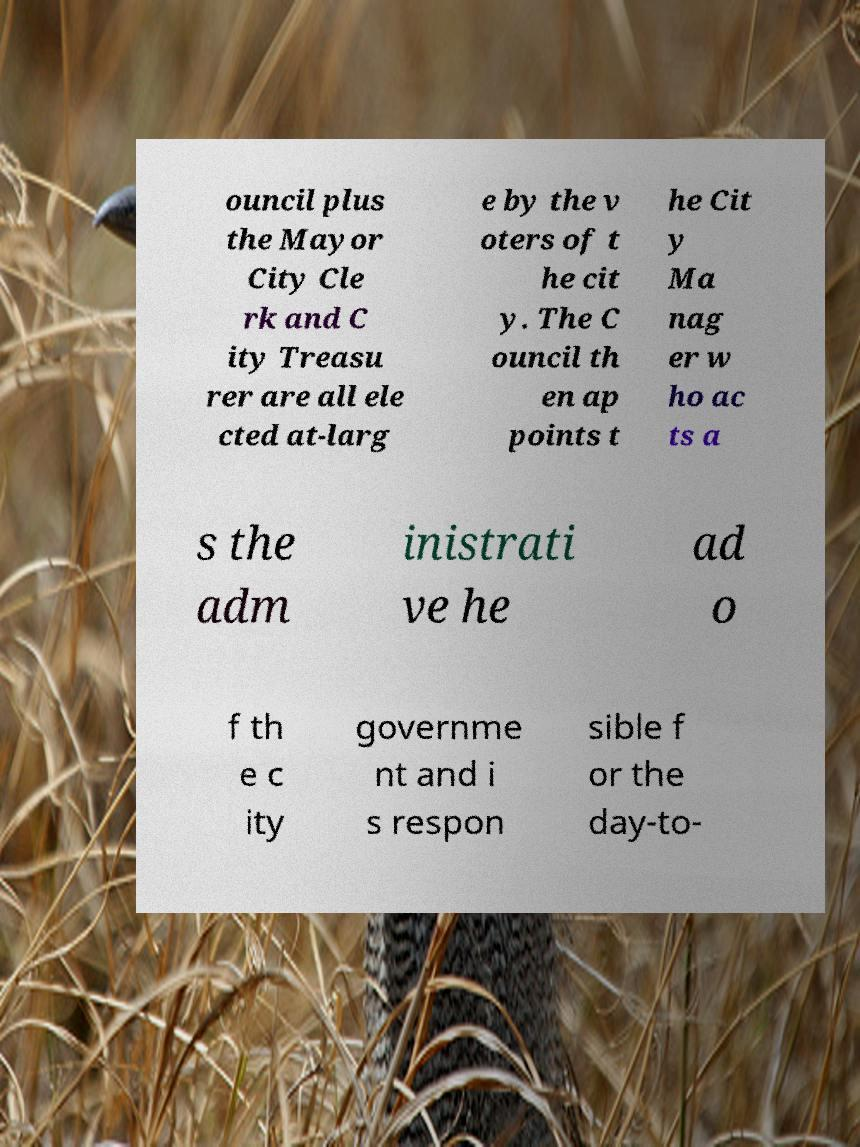I need the written content from this picture converted into text. Can you do that? ouncil plus the Mayor City Cle rk and C ity Treasu rer are all ele cted at-larg e by the v oters of t he cit y. The C ouncil th en ap points t he Cit y Ma nag er w ho ac ts a s the adm inistrati ve he ad o f th e c ity governme nt and i s respon sible f or the day-to- 